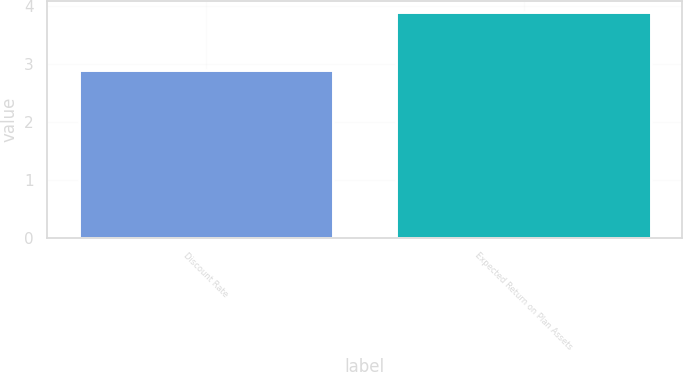<chart> <loc_0><loc_0><loc_500><loc_500><bar_chart><fcel>Discount Rate<fcel>Expected Return on Plan Assets<nl><fcel>2.9<fcel>3.9<nl></chart> 